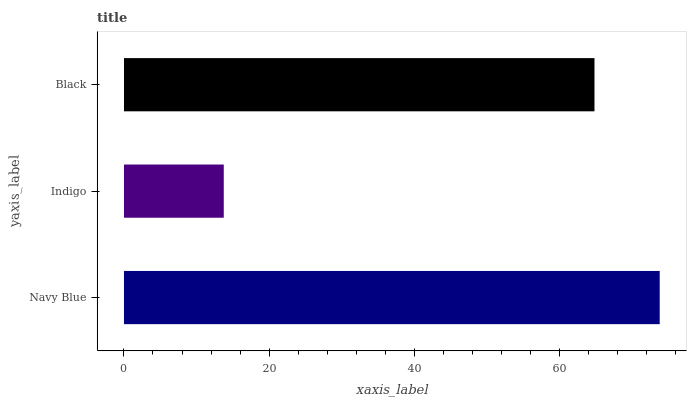Is Indigo the minimum?
Answer yes or no. Yes. Is Navy Blue the maximum?
Answer yes or no. Yes. Is Black the minimum?
Answer yes or no. No. Is Black the maximum?
Answer yes or no. No. Is Black greater than Indigo?
Answer yes or no. Yes. Is Indigo less than Black?
Answer yes or no. Yes. Is Indigo greater than Black?
Answer yes or no. No. Is Black less than Indigo?
Answer yes or no. No. Is Black the high median?
Answer yes or no. Yes. Is Black the low median?
Answer yes or no. Yes. Is Indigo the high median?
Answer yes or no. No. Is Indigo the low median?
Answer yes or no. No. 